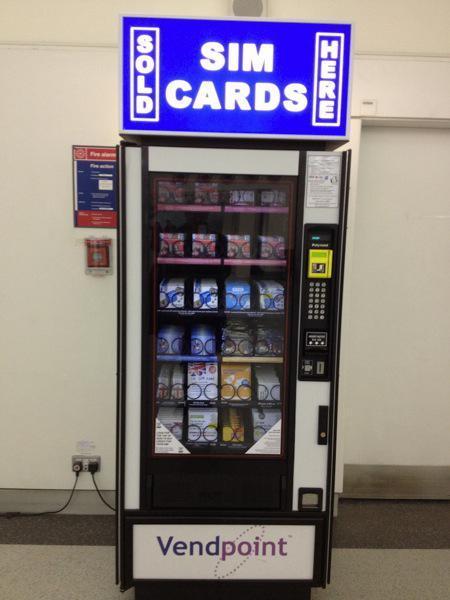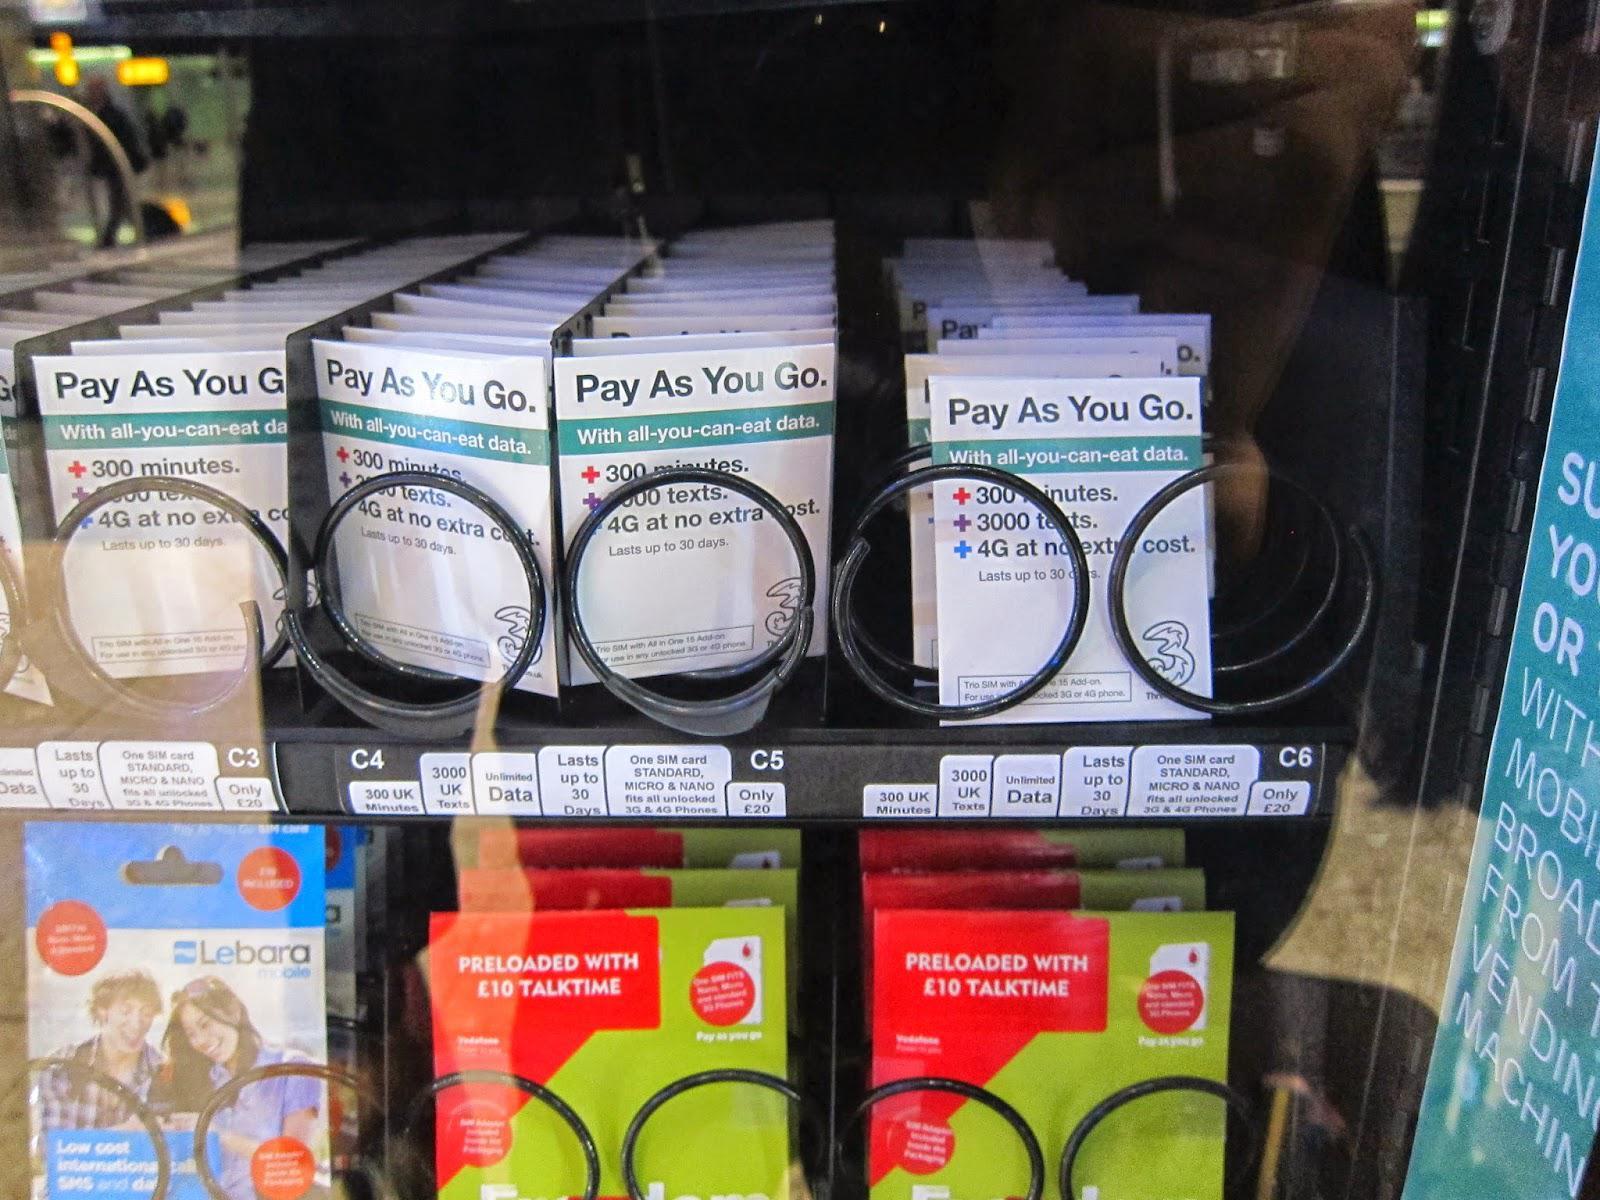The first image is the image on the left, the second image is the image on the right. Considering the images on both sides, is "There is a single Sim card vending  with a large blue sign set against a white wall." valid? Answer yes or no. Yes. The first image is the image on the left, the second image is the image on the right. Assess this claim about the two images: "You can clearly see that the vending machine on the left is up against a solid wall.". Correct or not? Answer yes or no. Yes. 